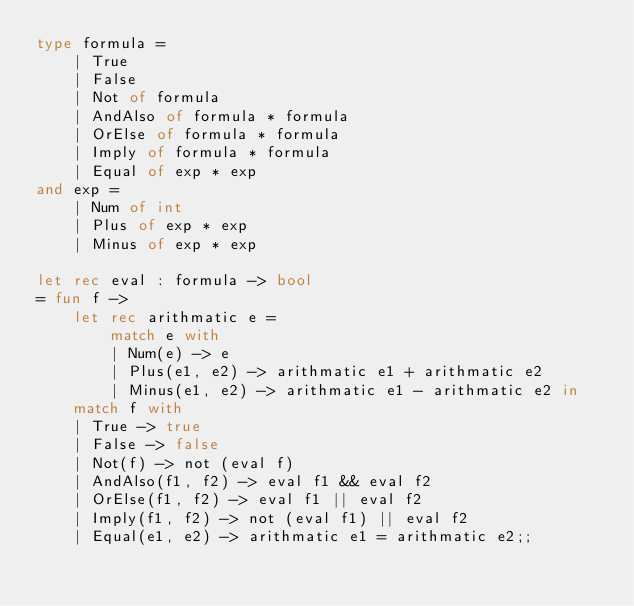<code> <loc_0><loc_0><loc_500><loc_500><_OCaml_>type formula =
	| True
	| False 
	| Not of formula 
	| AndAlso of formula * formula 
	| OrElse of formula * formula 
	| Imply of formula * formula 
	| Equal of exp * exp
and exp = 
	| Num of int 
	| Plus of exp * exp 
	| Minus of exp * exp

let rec eval : formula -> bool
= fun f -> 
	let rec arithmatic e = 
		match e with
		| Num(e) -> e
		| Plus(e1, e2) -> arithmatic e1 + arithmatic e2
		| Minus(e1, e2) -> arithmatic e1 - arithmatic e2 in
	match f with
	| True -> true
	| False -> false
	| Not(f) -> not (eval f)
	| AndAlso(f1, f2) -> eval f1 && eval f2
	| OrElse(f1, f2) -> eval f1 || eval f2
	| Imply(f1, f2) -> not (eval f1) || eval f2
	| Equal(e1, e2) -> arithmatic e1 = arithmatic e2;;</code> 